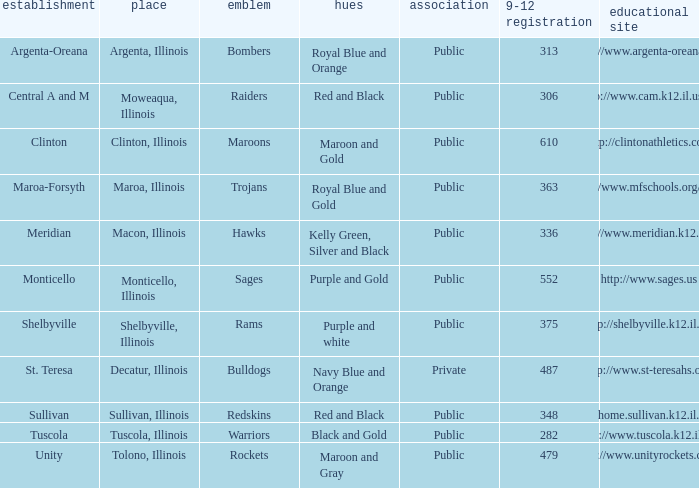What are the team colors from Tolono, Illinois? Maroon and Gray. Could you parse the entire table as a dict? {'header': ['establishment', 'place', 'emblem', 'hues', 'association', '9-12 registration', 'educational site'], 'rows': [['Argenta-Oreana', 'Argenta, Illinois', 'Bombers', 'Royal Blue and Orange', 'Public', '313', 'http://www.argenta-oreana.org'], ['Central A and M', 'Moweaqua, Illinois', 'Raiders', 'Red and Black', 'Public', '306', 'http://www.cam.k12.il.us/hs'], ['Clinton', 'Clinton, Illinois', 'Maroons', 'Maroon and Gold', 'Public', '610', 'http://clintonathletics.com'], ['Maroa-Forsyth', 'Maroa, Illinois', 'Trojans', 'Royal Blue and Gold', 'Public', '363', 'http://www.mfschools.org/high/'], ['Meridian', 'Macon, Illinois', 'Hawks', 'Kelly Green, Silver and Black', 'Public', '336', 'http://www.meridian.k12.il.us/'], ['Monticello', 'Monticello, Illinois', 'Sages', 'Purple and Gold', 'Public', '552', 'http://www.sages.us'], ['Shelbyville', 'Shelbyville, Illinois', 'Rams', 'Purple and white', 'Public', '375', 'http://shelbyville.k12.il.us/'], ['St. Teresa', 'Decatur, Illinois', 'Bulldogs', 'Navy Blue and Orange', 'Private', '487', 'http://www.st-teresahs.org/'], ['Sullivan', 'Sullivan, Illinois', 'Redskins', 'Red and Black', 'Public', '348', 'http://home.sullivan.k12.il.us/shs'], ['Tuscola', 'Tuscola, Illinois', 'Warriors', 'Black and Gold', 'Public', '282', 'http://www.tuscola.k12.il.us/'], ['Unity', 'Tolono, Illinois', 'Rockets', 'Maroon and Gray', 'Public', '479', 'http://www.unityrockets.com/']]} 